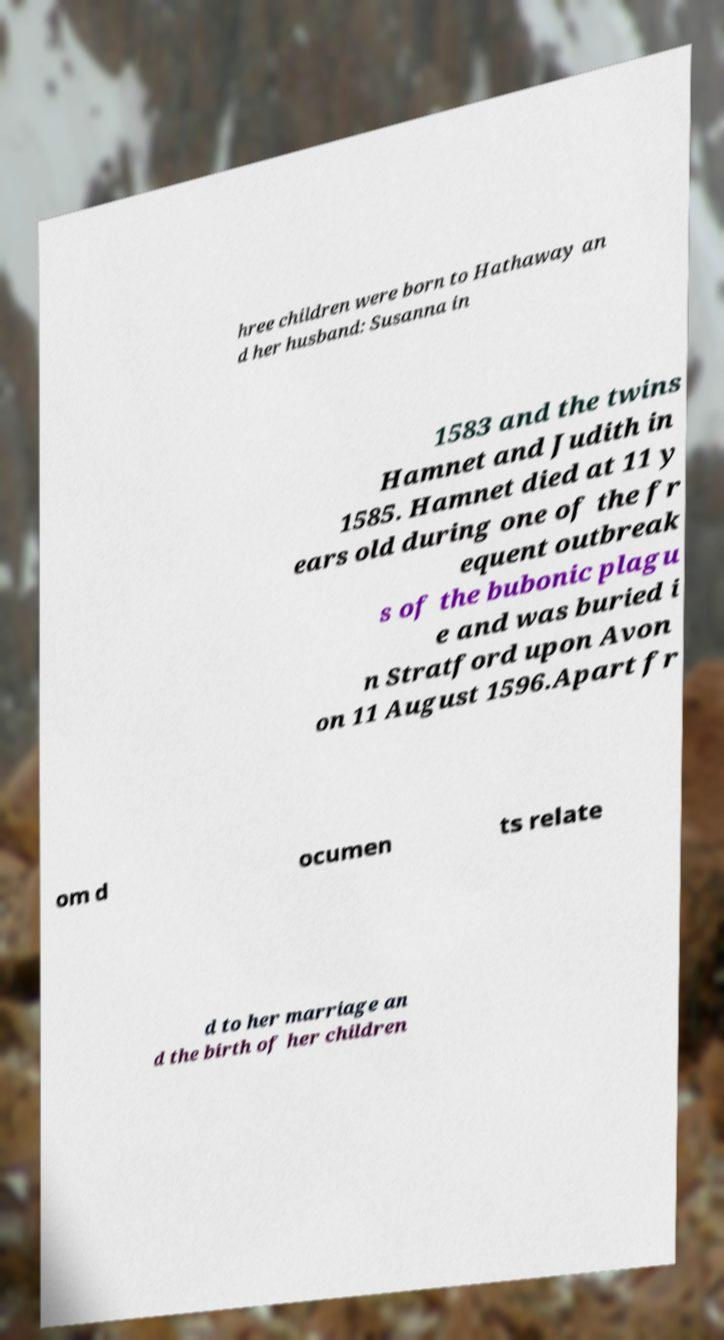Please read and relay the text visible in this image. What does it say? hree children were born to Hathaway an d her husband: Susanna in 1583 and the twins Hamnet and Judith in 1585. Hamnet died at 11 y ears old during one of the fr equent outbreak s of the bubonic plagu e and was buried i n Stratford upon Avon on 11 August 1596.Apart fr om d ocumen ts relate d to her marriage an d the birth of her children 